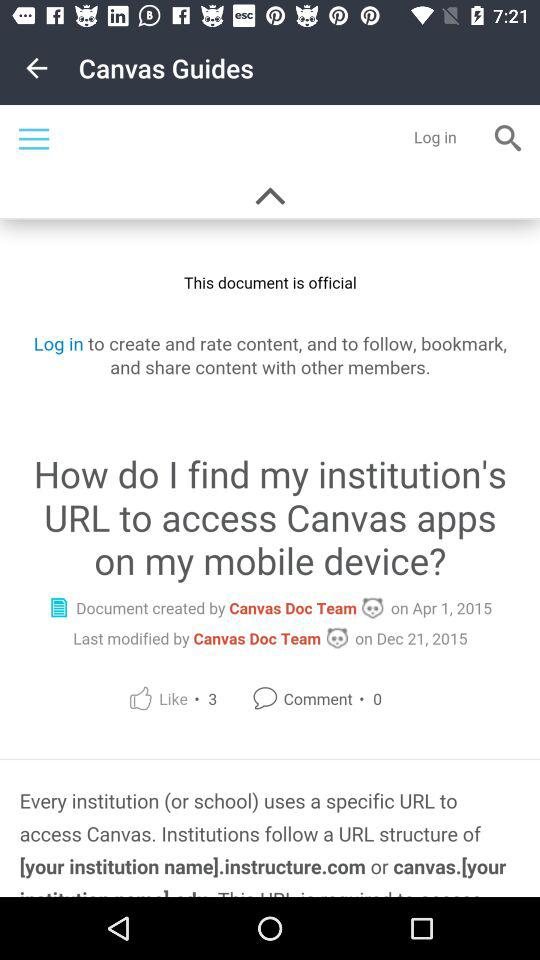What is the title of the article given on the screen? The given title is "How do I find my institution's URL to access Canvas apps on my mobile device?". 